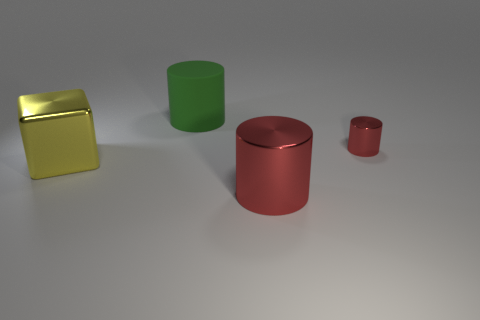Add 3 big objects. How many objects exist? 7 Subtract all red blocks. How many red cylinders are left? 2 Subtract all big matte cylinders. How many cylinders are left? 2 Subtract all cubes. How many objects are left? 3 Subtract all cylinders. Subtract all tiny brown rubber things. How many objects are left? 1 Add 4 metallic blocks. How many metallic blocks are left? 5 Add 1 small shiny cylinders. How many small shiny cylinders exist? 2 Subtract 1 yellow blocks. How many objects are left? 3 Subtract all brown cubes. Subtract all gray cylinders. How many cubes are left? 1 